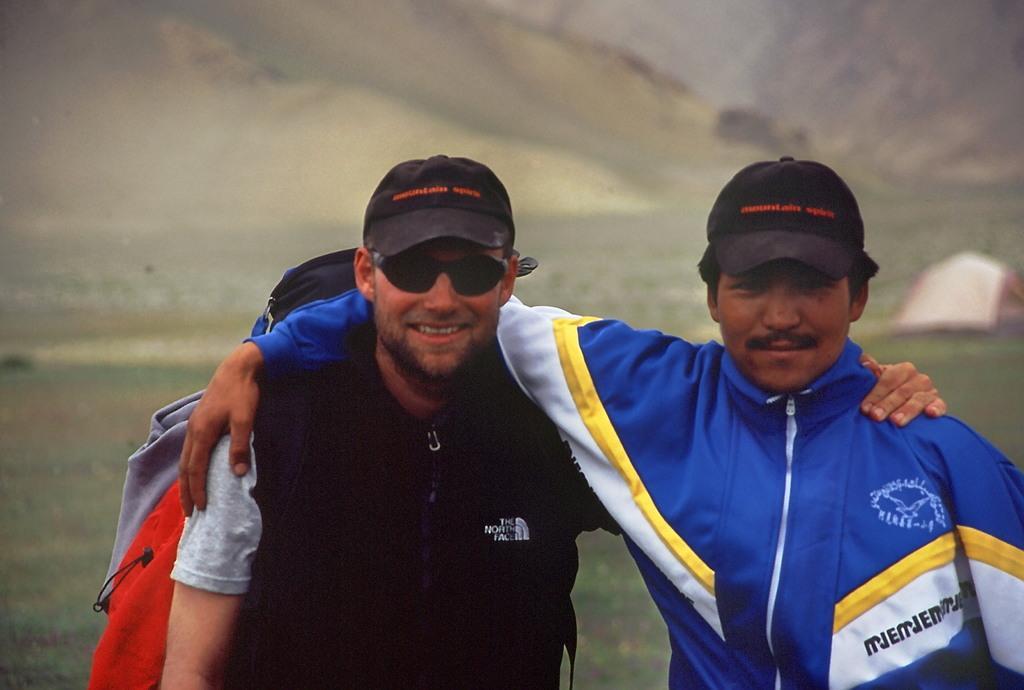How would you summarize this image in a sentence or two? In the center of the image there are two persons standing wearing a black color cap. In the background of the image there is grass. There is tent to the right side of the image. 